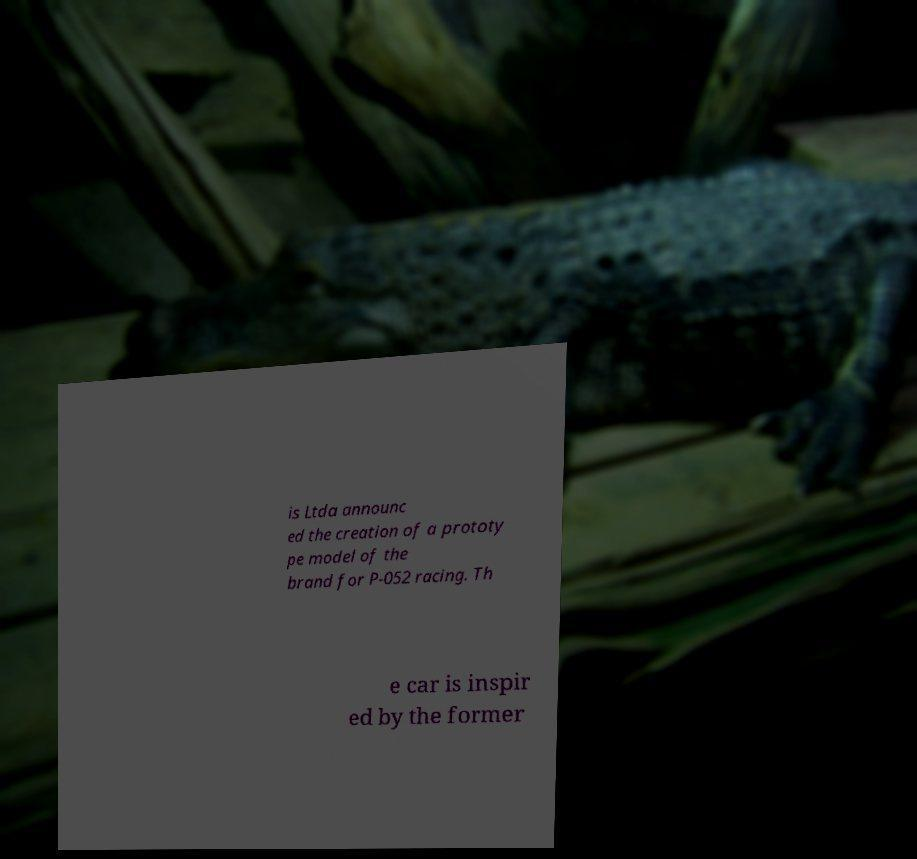Can you accurately transcribe the text from the provided image for me? is Ltda announc ed the creation of a prototy pe model of the brand for P-052 racing. Th e car is inspir ed by the former 